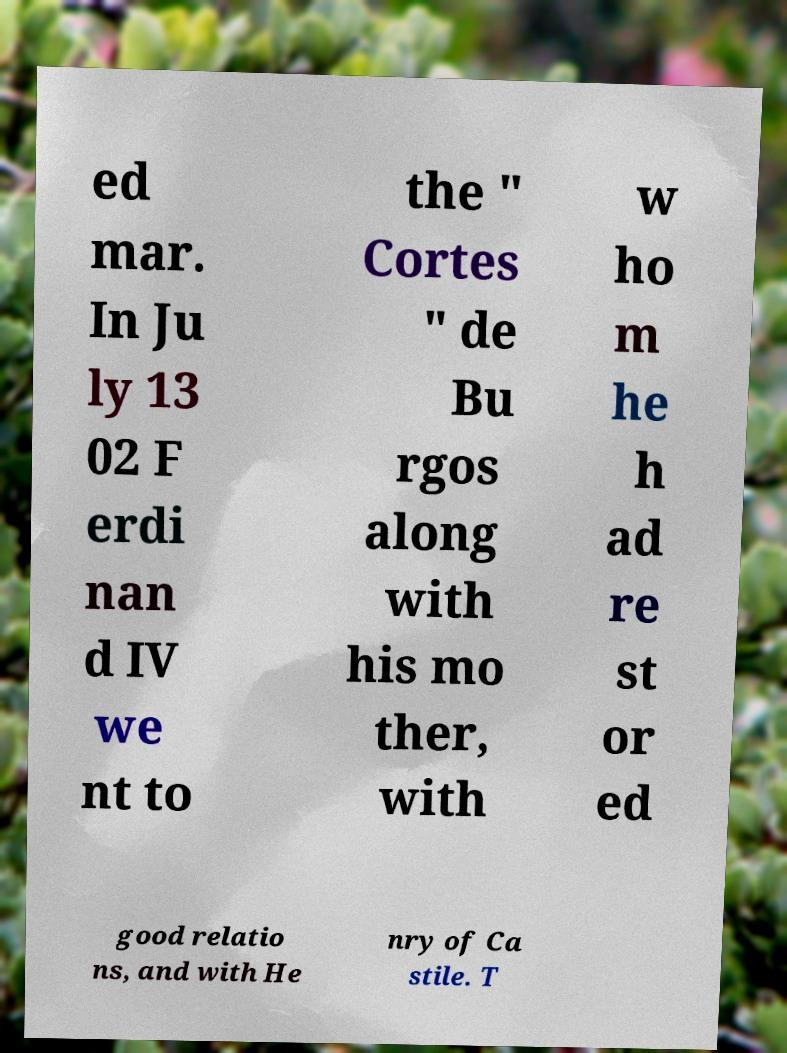Can you accurately transcribe the text from the provided image for me? ed mar. In Ju ly 13 02 F erdi nan d IV we nt to the " Cortes " de Bu rgos along with his mo ther, with w ho m he h ad re st or ed good relatio ns, and with He nry of Ca stile. T 